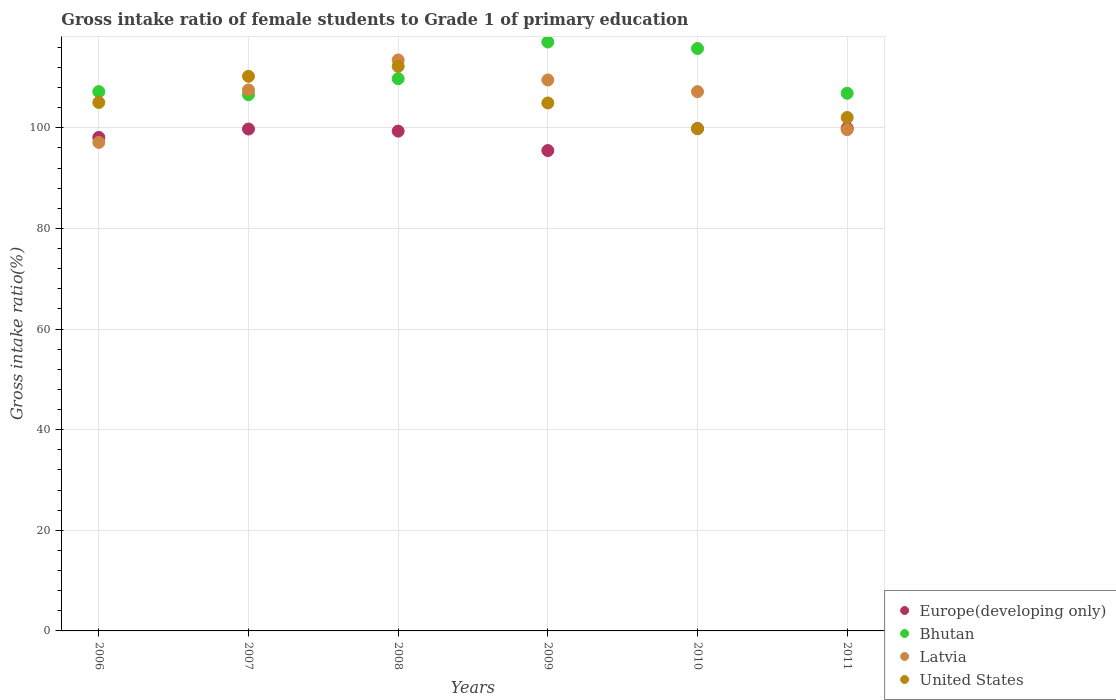How many different coloured dotlines are there?
Make the answer very short. 4. What is the gross intake ratio in Europe(developing only) in 2008?
Keep it short and to the point. 99.34. Across all years, what is the maximum gross intake ratio in Latvia?
Offer a terse response. 113.48. Across all years, what is the minimum gross intake ratio in Bhutan?
Your answer should be very brief. 106.58. In which year was the gross intake ratio in United States minimum?
Provide a short and direct response. 2010. What is the total gross intake ratio in Latvia in the graph?
Your answer should be compact. 634.45. What is the difference between the gross intake ratio in Bhutan in 2007 and that in 2011?
Offer a very short reply. -0.28. What is the difference between the gross intake ratio in Bhutan in 2006 and the gross intake ratio in Europe(developing only) in 2008?
Your answer should be very brief. 7.85. What is the average gross intake ratio in Bhutan per year?
Your answer should be compact. 110.54. In the year 2007, what is the difference between the gross intake ratio in Europe(developing only) and gross intake ratio in Bhutan?
Offer a very short reply. -6.82. In how many years, is the gross intake ratio in Europe(developing only) greater than 76 %?
Offer a terse response. 6. What is the ratio of the gross intake ratio in Latvia in 2006 to that in 2008?
Keep it short and to the point. 0.86. What is the difference between the highest and the second highest gross intake ratio in Bhutan?
Provide a short and direct response. 1.3. What is the difference between the highest and the lowest gross intake ratio in Europe(developing only)?
Provide a succinct answer. 4.46. In how many years, is the gross intake ratio in United States greater than the average gross intake ratio in United States taken over all years?
Your answer should be compact. 2. Is the gross intake ratio in Bhutan strictly greater than the gross intake ratio in Europe(developing only) over the years?
Provide a short and direct response. Yes. What is the difference between two consecutive major ticks on the Y-axis?
Ensure brevity in your answer.  20. How many legend labels are there?
Offer a terse response. 4. What is the title of the graph?
Give a very brief answer. Gross intake ratio of female students to Grade 1 of primary education. What is the label or title of the Y-axis?
Make the answer very short. Gross intake ratio(%). What is the Gross intake ratio(%) in Europe(developing only) in 2006?
Offer a terse response. 98.09. What is the Gross intake ratio(%) in Bhutan in 2006?
Give a very brief answer. 107.19. What is the Gross intake ratio(%) in Latvia in 2006?
Your response must be concise. 97.1. What is the Gross intake ratio(%) in United States in 2006?
Your answer should be very brief. 105.04. What is the Gross intake ratio(%) in Europe(developing only) in 2007?
Your answer should be very brief. 99.76. What is the Gross intake ratio(%) in Bhutan in 2007?
Your answer should be very brief. 106.58. What is the Gross intake ratio(%) of Latvia in 2007?
Provide a succinct answer. 107.53. What is the Gross intake ratio(%) of United States in 2007?
Your answer should be very brief. 110.24. What is the Gross intake ratio(%) in Europe(developing only) in 2008?
Your answer should be compact. 99.34. What is the Gross intake ratio(%) of Bhutan in 2008?
Provide a short and direct response. 109.76. What is the Gross intake ratio(%) in Latvia in 2008?
Your answer should be compact. 113.48. What is the Gross intake ratio(%) in United States in 2008?
Keep it short and to the point. 112.22. What is the Gross intake ratio(%) in Europe(developing only) in 2009?
Ensure brevity in your answer.  95.48. What is the Gross intake ratio(%) in Bhutan in 2009?
Provide a short and direct response. 117.06. What is the Gross intake ratio(%) in Latvia in 2009?
Ensure brevity in your answer.  109.51. What is the Gross intake ratio(%) in United States in 2009?
Provide a short and direct response. 104.94. What is the Gross intake ratio(%) of Europe(developing only) in 2010?
Keep it short and to the point. 99.87. What is the Gross intake ratio(%) in Bhutan in 2010?
Your answer should be compact. 115.76. What is the Gross intake ratio(%) of Latvia in 2010?
Your response must be concise. 107.19. What is the Gross intake ratio(%) in United States in 2010?
Your answer should be compact. 99.82. What is the Gross intake ratio(%) in Europe(developing only) in 2011?
Offer a very short reply. 99.94. What is the Gross intake ratio(%) in Bhutan in 2011?
Ensure brevity in your answer.  106.86. What is the Gross intake ratio(%) of Latvia in 2011?
Your response must be concise. 99.64. What is the Gross intake ratio(%) in United States in 2011?
Your response must be concise. 102.05. Across all years, what is the maximum Gross intake ratio(%) in Europe(developing only)?
Your answer should be very brief. 99.94. Across all years, what is the maximum Gross intake ratio(%) in Bhutan?
Your response must be concise. 117.06. Across all years, what is the maximum Gross intake ratio(%) of Latvia?
Make the answer very short. 113.48. Across all years, what is the maximum Gross intake ratio(%) of United States?
Your answer should be very brief. 112.22. Across all years, what is the minimum Gross intake ratio(%) in Europe(developing only)?
Your answer should be very brief. 95.48. Across all years, what is the minimum Gross intake ratio(%) of Bhutan?
Ensure brevity in your answer.  106.58. Across all years, what is the minimum Gross intake ratio(%) of Latvia?
Your answer should be very brief. 97.1. Across all years, what is the minimum Gross intake ratio(%) of United States?
Give a very brief answer. 99.82. What is the total Gross intake ratio(%) of Europe(developing only) in the graph?
Your answer should be very brief. 592.47. What is the total Gross intake ratio(%) in Bhutan in the graph?
Provide a short and direct response. 663.22. What is the total Gross intake ratio(%) in Latvia in the graph?
Give a very brief answer. 634.45. What is the total Gross intake ratio(%) in United States in the graph?
Offer a very short reply. 634.31. What is the difference between the Gross intake ratio(%) of Europe(developing only) in 2006 and that in 2007?
Make the answer very short. -1.67. What is the difference between the Gross intake ratio(%) in Bhutan in 2006 and that in 2007?
Keep it short and to the point. 0.61. What is the difference between the Gross intake ratio(%) in Latvia in 2006 and that in 2007?
Provide a succinct answer. -10.42. What is the difference between the Gross intake ratio(%) in United States in 2006 and that in 2007?
Make the answer very short. -5.2. What is the difference between the Gross intake ratio(%) of Europe(developing only) in 2006 and that in 2008?
Provide a succinct answer. -1.25. What is the difference between the Gross intake ratio(%) in Bhutan in 2006 and that in 2008?
Provide a short and direct response. -2.57. What is the difference between the Gross intake ratio(%) in Latvia in 2006 and that in 2008?
Give a very brief answer. -16.38. What is the difference between the Gross intake ratio(%) of United States in 2006 and that in 2008?
Your response must be concise. -7.18. What is the difference between the Gross intake ratio(%) of Europe(developing only) in 2006 and that in 2009?
Your answer should be very brief. 2.61. What is the difference between the Gross intake ratio(%) of Bhutan in 2006 and that in 2009?
Give a very brief answer. -9.86. What is the difference between the Gross intake ratio(%) of Latvia in 2006 and that in 2009?
Offer a terse response. -12.41. What is the difference between the Gross intake ratio(%) of United States in 2006 and that in 2009?
Keep it short and to the point. 0.1. What is the difference between the Gross intake ratio(%) in Europe(developing only) in 2006 and that in 2010?
Offer a very short reply. -1.77. What is the difference between the Gross intake ratio(%) of Bhutan in 2006 and that in 2010?
Keep it short and to the point. -8.57. What is the difference between the Gross intake ratio(%) in Latvia in 2006 and that in 2010?
Make the answer very short. -10.09. What is the difference between the Gross intake ratio(%) of United States in 2006 and that in 2010?
Make the answer very short. 5.21. What is the difference between the Gross intake ratio(%) in Europe(developing only) in 2006 and that in 2011?
Provide a succinct answer. -1.85. What is the difference between the Gross intake ratio(%) in Bhutan in 2006 and that in 2011?
Keep it short and to the point. 0.33. What is the difference between the Gross intake ratio(%) in Latvia in 2006 and that in 2011?
Keep it short and to the point. -2.54. What is the difference between the Gross intake ratio(%) of United States in 2006 and that in 2011?
Ensure brevity in your answer.  2.98. What is the difference between the Gross intake ratio(%) in Europe(developing only) in 2007 and that in 2008?
Provide a succinct answer. 0.42. What is the difference between the Gross intake ratio(%) in Bhutan in 2007 and that in 2008?
Keep it short and to the point. -3.18. What is the difference between the Gross intake ratio(%) in Latvia in 2007 and that in 2008?
Keep it short and to the point. -5.96. What is the difference between the Gross intake ratio(%) of United States in 2007 and that in 2008?
Offer a terse response. -1.98. What is the difference between the Gross intake ratio(%) of Europe(developing only) in 2007 and that in 2009?
Offer a very short reply. 4.28. What is the difference between the Gross intake ratio(%) of Bhutan in 2007 and that in 2009?
Provide a short and direct response. -10.48. What is the difference between the Gross intake ratio(%) in Latvia in 2007 and that in 2009?
Ensure brevity in your answer.  -1.98. What is the difference between the Gross intake ratio(%) in United States in 2007 and that in 2009?
Provide a succinct answer. 5.3. What is the difference between the Gross intake ratio(%) of Europe(developing only) in 2007 and that in 2010?
Your answer should be compact. -0.1. What is the difference between the Gross intake ratio(%) of Bhutan in 2007 and that in 2010?
Offer a terse response. -9.18. What is the difference between the Gross intake ratio(%) in Latvia in 2007 and that in 2010?
Offer a terse response. 0.34. What is the difference between the Gross intake ratio(%) in United States in 2007 and that in 2010?
Provide a succinct answer. 10.41. What is the difference between the Gross intake ratio(%) of Europe(developing only) in 2007 and that in 2011?
Ensure brevity in your answer.  -0.17. What is the difference between the Gross intake ratio(%) of Bhutan in 2007 and that in 2011?
Keep it short and to the point. -0.28. What is the difference between the Gross intake ratio(%) of Latvia in 2007 and that in 2011?
Ensure brevity in your answer.  7.89. What is the difference between the Gross intake ratio(%) in United States in 2007 and that in 2011?
Your response must be concise. 8.19. What is the difference between the Gross intake ratio(%) in Europe(developing only) in 2008 and that in 2009?
Keep it short and to the point. 3.86. What is the difference between the Gross intake ratio(%) in Bhutan in 2008 and that in 2009?
Offer a terse response. -7.29. What is the difference between the Gross intake ratio(%) in Latvia in 2008 and that in 2009?
Your response must be concise. 3.97. What is the difference between the Gross intake ratio(%) in United States in 2008 and that in 2009?
Offer a very short reply. 7.29. What is the difference between the Gross intake ratio(%) in Europe(developing only) in 2008 and that in 2010?
Provide a succinct answer. -0.53. What is the difference between the Gross intake ratio(%) of Bhutan in 2008 and that in 2010?
Your answer should be very brief. -6. What is the difference between the Gross intake ratio(%) of Latvia in 2008 and that in 2010?
Your response must be concise. 6.3. What is the difference between the Gross intake ratio(%) of United States in 2008 and that in 2010?
Provide a succinct answer. 12.4. What is the difference between the Gross intake ratio(%) of Europe(developing only) in 2008 and that in 2011?
Your answer should be compact. -0.6. What is the difference between the Gross intake ratio(%) of Bhutan in 2008 and that in 2011?
Give a very brief answer. 2.9. What is the difference between the Gross intake ratio(%) in Latvia in 2008 and that in 2011?
Make the answer very short. 13.85. What is the difference between the Gross intake ratio(%) in United States in 2008 and that in 2011?
Your answer should be compact. 10.17. What is the difference between the Gross intake ratio(%) in Europe(developing only) in 2009 and that in 2010?
Offer a very short reply. -4.39. What is the difference between the Gross intake ratio(%) of Bhutan in 2009 and that in 2010?
Provide a succinct answer. 1.3. What is the difference between the Gross intake ratio(%) of Latvia in 2009 and that in 2010?
Provide a succinct answer. 2.32. What is the difference between the Gross intake ratio(%) in United States in 2009 and that in 2010?
Give a very brief answer. 5.11. What is the difference between the Gross intake ratio(%) of Europe(developing only) in 2009 and that in 2011?
Your answer should be very brief. -4.46. What is the difference between the Gross intake ratio(%) of Bhutan in 2009 and that in 2011?
Provide a succinct answer. 10.19. What is the difference between the Gross intake ratio(%) in Latvia in 2009 and that in 2011?
Offer a very short reply. 9.87. What is the difference between the Gross intake ratio(%) in United States in 2009 and that in 2011?
Provide a short and direct response. 2.88. What is the difference between the Gross intake ratio(%) in Europe(developing only) in 2010 and that in 2011?
Your answer should be compact. -0.07. What is the difference between the Gross intake ratio(%) in Bhutan in 2010 and that in 2011?
Your answer should be compact. 8.9. What is the difference between the Gross intake ratio(%) of Latvia in 2010 and that in 2011?
Offer a terse response. 7.55. What is the difference between the Gross intake ratio(%) in United States in 2010 and that in 2011?
Ensure brevity in your answer.  -2.23. What is the difference between the Gross intake ratio(%) of Europe(developing only) in 2006 and the Gross intake ratio(%) of Bhutan in 2007?
Your answer should be very brief. -8.49. What is the difference between the Gross intake ratio(%) in Europe(developing only) in 2006 and the Gross intake ratio(%) in Latvia in 2007?
Provide a short and direct response. -9.44. What is the difference between the Gross intake ratio(%) of Europe(developing only) in 2006 and the Gross intake ratio(%) of United States in 2007?
Offer a very short reply. -12.15. What is the difference between the Gross intake ratio(%) in Bhutan in 2006 and the Gross intake ratio(%) in Latvia in 2007?
Your answer should be very brief. -0.33. What is the difference between the Gross intake ratio(%) in Bhutan in 2006 and the Gross intake ratio(%) in United States in 2007?
Your answer should be compact. -3.04. What is the difference between the Gross intake ratio(%) in Latvia in 2006 and the Gross intake ratio(%) in United States in 2007?
Keep it short and to the point. -13.14. What is the difference between the Gross intake ratio(%) of Europe(developing only) in 2006 and the Gross intake ratio(%) of Bhutan in 2008?
Keep it short and to the point. -11.67. What is the difference between the Gross intake ratio(%) in Europe(developing only) in 2006 and the Gross intake ratio(%) in Latvia in 2008?
Keep it short and to the point. -15.39. What is the difference between the Gross intake ratio(%) in Europe(developing only) in 2006 and the Gross intake ratio(%) in United States in 2008?
Offer a terse response. -14.13. What is the difference between the Gross intake ratio(%) of Bhutan in 2006 and the Gross intake ratio(%) of Latvia in 2008?
Your answer should be compact. -6.29. What is the difference between the Gross intake ratio(%) in Bhutan in 2006 and the Gross intake ratio(%) in United States in 2008?
Give a very brief answer. -5.03. What is the difference between the Gross intake ratio(%) in Latvia in 2006 and the Gross intake ratio(%) in United States in 2008?
Offer a very short reply. -15.12. What is the difference between the Gross intake ratio(%) of Europe(developing only) in 2006 and the Gross intake ratio(%) of Bhutan in 2009?
Provide a short and direct response. -18.97. What is the difference between the Gross intake ratio(%) of Europe(developing only) in 2006 and the Gross intake ratio(%) of Latvia in 2009?
Provide a short and direct response. -11.42. What is the difference between the Gross intake ratio(%) in Europe(developing only) in 2006 and the Gross intake ratio(%) in United States in 2009?
Make the answer very short. -6.84. What is the difference between the Gross intake ratio(%) of Bhutan in 2006 and the Gross intake ratio(%) of Latvia in 2009?
Keep it short and to the point. -2.32. What is the difference between the Gross intake ratio(%) in Bhutan in 2006 and the Gross intake ratio(%) in United States in 2009?
Offer a very short reply. 2.26. What is the difference between the Gross intake ratio(%) of Latvia in 2006 and the Gross intake ratio(%) of United States in 2009?
Your response must be concise. -7.83. What is the difference between the Gross intake ratio(%) of Europe(developing only) in 2006 and the Gross intake ratio(%) of Bhutan in 2010?
Offer a very short reply. -17.67. What is the difference between the Gross intake ratio(%) of Europe(developing only) in 2006 and the Gross intake ratio(%) of Latvia in 2010?
Ensure brevity in your answer.  -9.1. What is the difference between the Gross intake ratio(%) of Europe(developing only) in 2006 and the Gross intake ratio(%) of United States in 2010?
Offer a very short reply. -1.73. What is the difference between the Gross intake ratio(%) of Bhutan in 2006 and the Gross intake ratio(%) of Latvia in 2010?
Your answer should be very brief. 0.01. What is the difference between the Gross intake ratio(%) of Bhutan in 2006 and the Gross intake ratio(%) of United States in 2010?
Offer a very short reply. 7.37. What is the difference between the Gross intake ratio(%) of Latvia in 2006 and the Gross intake ratio(%) of United States in 2010?
Offer a terse response. -2.72. What is the difference between the Gross intake ratio(%) of Europe(developing only) in 2006 and the Gross intake ratio(%) of Bhutan in 2011?
Provide a short and direct response. -8.77. What is the difference between the Gross intake ratio(%) in Europe(developing only) in 2006 and the Gross intake ratio(%) in Latvia in 2011?
Ensure brevity in your answer.  -1.55. What is the difference between the Gross intake ratio(%) of Europe(developing only) in 2006 and the Gross intake ratio(%) of United States in 2011?
Your response must be concise. -3.96. What is the difference between the Gross intake ratio(%) of Bhutan in 2006 and the Gross intake ratio(%) of Latvia in 2011?
Provide a short and direct response. 7.56. What is the difference between the Gross intake ratio(%) in Bhutan in 2006 and the Gross intake ratio(%) in United States in 2011?
Offer a very short reply. 5.14. What is the difference between the Gross intake ratio(%) of Latvia in 2006 and the Gross intake ratio(%) of United States in 2011?
Make the answer very short. -4.95. What is the difference between the Gross intake ratio(%) in Europe(developing only) in 2007 and the Gross intake ratio(%) in Bhutan in 2008?
Ensure brevity in your answer.  -10. What is the difference between the Gross intake ratio(%) in Europe(developing only) in 2007 and the Gross intake ratio(%) in Latvia in 2008?
Give a very brief answer. -13.72. What is the difference between the Gross intake ratio(%) of Europe(developing only) in 2007 and the Gross intake ratio(%) of United States in 2008?
Give a very brief answer. -12.46. What is the difference between the Gross intake ratio(%) of Bhutan in 2007 and the Gross intake ratio(%) of Latvia in 2008?
Provide a short and direct response. -6.9. What is the difference between the Gross intake ratio(%) of Bhutan in 2007 and the Gross intake ratio(%) of United States in 2008?
Your response must be concise. -5.64. What is the difference between the Gross intake ratio(%) of Latvia in 2007 and the Gross intake ratio(%) of United States in 2008?
Make the answer very short. -4.69. What is the difference between the Gross intake ratio(%) of Europe(developing only) in 2007 and the Gross intake ratio(%) of Bhutan in 2009?
Give a very brief answer. -17.29. What is the difference between the Gross intake ratio(%) in Europe(developing only) in 2007 and the Gross intake ratio(%) in Latvia in 2009?
Provide a short and direct response. -9.75. What is the difference between the Gross intake ratio(%) of Europe(developing only) in 2007 and the Gross intake ratio(%) of United States in 2009?
Your answer should be compact. -5.17. What is the difference between the Gross intake ratio(%) of Bhutan in 2007 and the Gross intake ratio(%) of Latvia in 2009?
Make the answer very short. -2.93. What is the difference between the Gross intake ratio(%) of Bhutan in 2007 and the Gross intake ratio(%) of United States in 2009?
Ensure brevity in your answer.  1.65. What is the difference between the Gross intake ratio(%) of Latvia in 2007 and the Gross intake ratio(%) of United States in 2009?
Provide a succinct answer. 2.59. What is the difference between the Gross intake ratio(%) in Europe(developing only) in 2007 and the Gross intake ratio(%) in Bhutan in 2010?
Keep it short and to the point. -16. What is the difference between the Gross intake ratio(%) of Europe(developing only) in 2007 and the Gross intake ratio(%) of Latvia in 2010?
Keep it short and to the point. -7.43. What is the difference between the Gross intake ratio(%) of Europe(developing only) in 2007 and the Gross intake ratio(%) of United States in 2010?
Ensure brevity in your answer.  -0.06. What is the difference between the Gross intake ratio(%) in Bhutan in 2007 and the Gross intake ratio(%) in Latvia in 2010?
Your answer should be compact. -0.61. What is the difference between the Gross intake ratio(%) of Bhutan in 2007 and the Gross intake ratio(%) of United States in 2010?
Ensure brevity in your answer.  6.76. What is the difference between the Gross intake ratio(%) of Latvia in 2007 and the Gross intake ratio(%) of United States in 2010?
Offer a terse response. 7.7. What is the difference between the Gross intake ratio(%) of Europe(developing only) in 2007 and the Gross intake ratio(%) of Bhutan in 2011?
Provide a short and direct response. -7.1. What is the difference between the Gross intake ratio(%) in Europe(developing only) in 2007 and the Gross intake ratio(%) in Latvia in 2011?
Make the answer very short. 0.12. What is the difference between the Gross intake ratio(%) of Europe(developing only) in 2007 and the Gross intake ratio(%) of United States in 2011?
Your answer should be very brief. -2.29. What is the difference between the Gross intake ratio(%) of Bhutan in 2007 and the Gross intake ratio(%) of Latvia in 2011?
Give a very brief answer. 6.94. What is the difference between the Gross intake ratio(%) in Bhutan in 2007 and the Gross intake ratio(%) in United States in 2011?
Your answer should be compact. 4.53. What is the difference between the Gross intake ratio(%) of Latvia in 2007 and the Gross intake ratio(%) of United States in 2011?
Your response must be concise. 5.47. What is the difference between the Gross intake ratio(%) of Europe(developing only) in 2008 and the Gross intake ratio(%) of Bhutan in 2009?
Ensure brevity in your answer.  -17.72. What is the difference between the Gross intake ratio(%) of Europe(developing only) in 2008 and the Gross intake ratio(%) of Latvia in 2009?
Your response must be concise. -10.17. What is the difference between the Gross intake ratio(%) of Europe(developing only) in 2008 and the Gross intake ratio(%) of United States in 2009?
Ensure brevity in your answer.  -5.59. What is the difference between the Gross intake ratio(%) of Bhutan in 2008 and the Gross intake ratio(%) of Latvia in 2009?
Your answer should be compact. 0.25. What is the difference between the Gross intake ratio(%) of Bhutan in 2008 and the Gross intake ratio(%) of United States in 2009?
Your answer should be compact. 4.83. What is the difference between the Gross intake ratio(%) of Latvia in 2008 and the Gross intake ratio(%) of United States in 2009?
Make the answer very short. 8.55. What is the difference between the Gross intake ratio(%) of Europe(developing only) in 2008 and the Gross intake ratio(%) of Bhutan in 2010?
Give a very brief answer. -16.42. What is the difference between the Gross intake ratio(%) of Europe(developing only) in 2008 and the Gross intake ratio(%) of Latvia in 2010?
Keep it short and to the point. -7.85. What is the difference between the Gross intake ratio(%) of Europe(developing only) in 2008 and the Gross intake ratio(%) of United States in 2010?
Provide a succinct answer. -0.48. What is the difference between the Gross intake ratio(%) in Bhutan in 2008 and the Gross intake ratio(%) in Latvia in 2010?
Provide a succinct answer. 2.57. What is the difference between the Gross intake ratio(%) of Bhutan in 2008 and the Gross intake ratio(%) of United States in 2010?
Offer a terse response. 9.94. What is the difference between the Gross intake ratio(%) in Latvia in 2008 and the Gross intake ratio(%) in United States in 2010?
Provide a succinct answer. 13.66. What is the difference between the Gross intake ratio(%) in Europe(developing only) in 2008 and the Gross intake ratio(%) in Bhutan in 2011?
Your answer should be very brief. -7.52. What is the difference between the Gross intake ratio(%) in Europe(developing only) in 2008 and the Gross intake ratio(%) in Latvia in 2011?
Your answer should be very brief. -0.3. What is the difference between the Gross intake ratio(%) of Europe(developing only) in 2008 and the Gross intake ratio(%) of United States in 2011?
Offer a terse response. -2.71. What is the difference between the Gross intake ratio(%) of Bhutan in 2008 and the Gross intake ratio(%) of Latvia in 2011?
Provide a short and direct response. 10.12. What is the difference between the Gross intake ratio(%) in Bhutan in 2008 and the Gross intake ratio(%) in United States in 2011?
Ensure brevity in your answer.  7.71. What is the difference between the Gross intake ratio(%) in Latvia in 2008 and the Gross intake ratio(%) in United States in 2011?
Your response must be concise. 11.43. What is the difference between the Gross intake ratio(%) in Europe(developing only) in 2009 and the Gross intake ratio(%) in Bhutan in 2010?
Ensure brevity in your answer.  -20.28. What is the difference between the Gross intake ratio(%) in Europe(developing only) in 2009 and the Gross intake ratio(%) in Latvia in 2010?
Provide a short and direct response. -11.71. What is the difference between the Gross intake ratio(%) in Europe(developing only) in 2009 and the Gross intake ratio(%) in United States in 2010?
Provide a succinct answer. -4.35. What is the difference between the Gross intake ratio(%) in Bhutan in 2009 and the Gross intake ratio(%) in Latvia in 2010?
Keep it short and to the point. 9.87. What is the difference between the Gross intake ratio(%) in Bhutan in 2009 and the Gross intake ratio(%) in United States in 2010?
Your answer should be very brief. 17.23. What is the difference between the Gross intake ratio(%) in Latvia in 2009 and the Gross intake ratio(%) in United States in 2010?
Your answer should be compact. 9.69. What is the difference between the Gross intake ratio(%) of Europe(developing only) in 2009 and the Gross intake ratio(%) of Bhutan in 2011?
Give a very brief answer. -11.38. What is the difference between the Gross intake ratio(%) in Europe(developing only) in 2009 and the Gross intake ratio(%) in Latvia in 2011?
Your response must be concise. -4.16. What is the difference between the Gross intake ratio(%) in Europe(developing only) in 2009 and the Gross intake ratio(%) in United States in 2011?
Provide a short and direct response. -6.57. What is the difference between the Gross intake ratio(%) of Bhutan in 2009 and the Gross intake ratio(%) of Latvia in 2011?
Your response must be concise. 17.42. What is the difference between the Gross intake ratio(%) in Bhutan in 2009 and the Gross intake ratio(%) in United States in 2011?
Your answer should be compact. 15. What is the difference between the Gross intake ratio(%) of Latvia in 2009 and the Gross intake ratio(%) of United States in 2011?
Offer a very short reply. 7.46. What is the difference between the Gross intake ratio(%) of Europe(developing only) in 2010 and the Gross intake ratio(%) of Bhutan in 2011?
Keep it short and to the point. -7. What is the difference between the Gross intake ratio(%) of Europe(developing only) in 2010 and the Gross intake ratio(%) of Latvia in 2011?
Make the answer very short. 0.23. What is the difference between the Gross intake ratio(%) of Europe(developing only) in 2010 and the Gross intake ratio(%) of United States in 2011?
Keep it short and to the point. -2.19. What is the difference between the Gross intake ratio(%) of Bhutan in 2010 and the Gross intake ratio(%) of Latvia in 2011?
Give a very brief answer. 16.12. What is the difference between the Gross intake ratio(%) of Bhutan in 2010 and the Gross intake ratio(%) of United States in 2011?
Give a very brief answer. 13.71. What is the difference between the Gross intake ratio(%) in Latvia in 2010 and the Gross intake ratio(%) in United States in 2011?
Offer a terse response. 5.14. What is the average Gross intake ratio(%) of Europe(developing only) per year?
Keep it short and to the point. 98.75. What is the average Gross intake ratio(%) of Bhutan per year?
Give a very brief answer. 110.54. What is the average Gross intake ratio(%) in Latvia per year?
Give a very brief answer. 105.74. What is the average Gross intake ratio(%) of United States per year?
Your answer should be compact. 105.72. In the year 2006, what is the difference between the Gross intake ratio(%) in Europe(developing only) and Gross intake ratio(%) in Bhutan?
Offer a terse response. -9.1. In the year 2006, what is the difference between the Gross intake ratio(%) in Europe(developing only) and Gross intake ratio(%) in Latvia?
Provide a short and direct response. 0.99. In the year 2006, what is the difference between the Gross intake ratio(%) of Europe(developing only) and Gross intake ratio(%) of United States?
Provide a short and direct response. -6.95. In the year 2006, what is the difference between the Gross intake ratio(%) in Bhutan and Gross intake ratio(%) in Latvia?
Offer a very short reply. 10.09. In the year 2006, what is the difference between the Gross intake ratio(%) in Bhutan and Gross intake ratio(%) in United States?
Provide a short and direct response. 2.16. In the year 2006, what is the difference between the Gross intake ratio(%) in Latvia and Gross intake ratio(%) in United States?
Your answer should be compact. -7.93. In the year 2007, what is the difference between the Gross intake ratio(%) of Europe(developing only) and Gross intake ratio(%) of Bhutan?
Your answer should be compact. -6.82. In the year 2007, what is the difference between the Gross intake ratio(%) in Europe(developing only) and Gross intake ratio(%) in Latvia?
Provide a succinct answer. -7.76. In the year 2007, what is the difference between the Gross intake ratio(%) of Europe(developing only) and Gross intake ratio(%) of United States?
Ensure brevity in your answer.  -10.48. In the year 2007, what is the difference between the Gross intake ratio(%) of Bhutan and Gross intake ratio(%) of Latvia?
Offer a terse response. -0.95. In the year 2007, what is the difference between the Gross intake ratio(%) in Bhutan and Gross intake ratio(%) in United States?
Make the answer very short. -3.66. In the year 2007, what is the difference between the Gross intake ratio(%) of Latvia and Gross intake ratio(%) of United States?
Ensure brevity in your answer.  -2.71. In the year 2008, what is the difference between the Gross intake ratio(%) of Europe(developing only) and Gross intake ratio(%) of Bhutan?
Your answer should be very brief. -10.42. In the year 2008, what is the difference between the Gross intake ratio(%) in Europe(developing only) and Gross intake ratio(%) in Latvia?
Your answer should be very brief. -14.14. In the year 2008, what is the difference between the Gross intake ratio(%) in Europe(developing only) and Gross intake ratio(%) in United States?
Provide a short and direct response. -12.88. In the year 2008, what is the difference between the Gross intake ratio(%) of Bhutan and Gross intake ratio(%) of Latvia?
Make the answer very short. -3.72. In the year 2008, what is the difference between the Gross intake ratio(%) of Bhutan and Gross intake ratio(%) of United States?
Make the answer very short. -2.46. In the year 2008, what is the difference between the Gross intake ratio(%) of Latvia and Gross intake ratio(%) of United States?
Keep it short and to the point. 1.26. In the year 2009, what is the difference between the Gross intake ratio(%) in Europe(developing only) and Gross intake ratio(%) in Bhutan?
Provide a succinct answer. -21.58. In the year 2009, what is the difference between the Gross intake ratio(%) in Europe(developing only) and Gross intake ratio(%) in Latvia?
Give a very brief answer. -14.03. In the year 2009, what is the difference between the Gross intake ratio(%) in Europe(developing only) and Gross intake ratio(%) in United States?
Provide a succinct answer. -9.46. In the year 2009, what is the difference between the Gross intake ratio(%) in Bhutan and Gross intake ratio(%) in Latvia?
Your answer should be compact. 7.55. In the year 2009, what is the difference between the Gross intake ratio(%) in Bhutan and Gross intake ratio(%) in United States?
Provide a short and direct response. 12.12. In the year 2009, what is the difference between the Gross intake ratio(%) in Latvia and Gross intake ratio(%) in United States?
Your answer should be very brief. 4.58. In the year 2010, what is the difference between the Gross intake ratio(%) in Europe(developing only) and Gross intake ratio(%) in Bhutan?
Provide a succinct answer. -15.9. In the year 2010, what is the difference between the Gross intake ratio(%) of Europe(developing only) and Gross intake ratio(%) of Latvia?
Offer a terse response. -7.32. In the year 2010, what is the difference between the Gross intake ratio(%) in Europe(developing only) and Gross intake ratio(%) in United States?
Offer a terse response. 0.04. In the year 2010, what is the difference between the Gross intake ratio(%) of Bhutan and Gross intake ratio(%) of Latvia?
Provide a succinct answer. 8.57. In the year 2010, what is the difference between the Gross intake ratio(%) of Bhutan and Gross intake ratio(%) of United States?
Your answer should be compact. 15.94. In the year 2010, what is the difference between the Gross intake ratio(%) in Latvia and Gross intake ratio(%) in United States?
Your answer should be compact. 7.36. In the year 2011, what is the difference between the Gross intake ratio(%) of Europe(developing only) and Gross intake ratio(%) of Bhutan?
Provide a short and direct response. -6.93. In the year 2011, what is the difference between the Gross intake ratio(%) of Europe(developing only) and Gross intake ratio(%) of Latvia?
Provide a short and direct response. 0.3. In the year 2011, what is the difference between the Gross intake ratio(%) in Europe(developing only) and Gross intake ratio(%) in United States?
Offer a very short reply. -2.12. In the year 2011, what is the difference between the Gross intake ratio(%) of Bhutan and Gross intake ratio(%) of Latvia?
Your answer should be very brief. 7.22. In the year 2011, what is the difference between the Gross intake ratio(%) in Bhutan and Gross intake ratio(%) in United States?
Give a very brief answer. 4.81. In the year 2011, what is the difference between the Gross intake ratio(%) in Latvia and Gross intake ratio(%) in United States?
Offer a terse response. -2.42. What is the ratio of the Gross intake ratio(%) of Europe(developing only) in 2006 to that in 2007?
Offer a terse response. 0.98. What is the ratio of the Gross intake ratio(%) of Bhutan in 2006 to that in 2007?
Offer a very short reply. 1.01. What is the ratio of the Gross intake ratio(%) of Latvia in 2006 to that in 2007?
Provide a short and direct response. 0.9. What is the ratio of the Gross intake ratio(%) in United States in 2006 to that in 2007?
Keep it short and to the point. 0.95. What is the ratio of the Gross intake ratio(%) of Europe(developing only) in 2006 to that in 2008?
Offer a terse response. 0.99. What is the ratio of the Gross intake ratio(%) in Bhutan in 2006 to that in 2008?
Provide a succinct answer. 0.98. What is the ratio of the Gross intake ratio(%) of Latvia in 2006 to that in 2008?
Your response must be concise. 0.86. What is the ratio of the Gross intake ratio(%) of United States in 2006 to that in 2008?
Your answer should be very brief. 0.94. What is the ratio of the Gross intake ratio(%) of Europe(developing only) in 2006 to that in 2009?
Provide a short and direct response. 1.03. What is the ratio of the Gross intake ratio(%) in Bhutan in 2006 to that in 2009?
Ensure brevity in your answer.  0.92. What is the ratio of the Gross intake ratio(%) in Latvia in 2006 to that in 2009?
Offer a very short reply. 0.89. What is the ratio of the Gross intake ratio(%) of Europe(developing only) in 2006 to that in 2010?
Give a very brief answer. 0.98. What is the ratio of the Gross intake ratio(%) in Bhutan in 2006 to that in 2010?
Your response must be concise. 0.93. What is the ratio of the Gross intake ratio(%) in Latvia in 2006 to that in 2010?
Provide a succinct answer. 0.91. What is the ratio of the Gross intake ratio(%) of United States in 2006 to that in 2010?
Your answer should be very brief. 1.05. What is the ratio of the Gross intake ratio(%) of Europe(developing only) in 2006 to that in 2011?
Ensure brevity in your answer.  0.98. What is the ratio of the Gross intake ratio(%) of Latvia in 2006 to that in 2011?
Your answer should be compact. 0.97. What is the ratio of the Gross intake ratio(%) in United States in 2006 to that in 2011?
Ensure brevity in your answer.  1.03. What is the ratio of the Gross intake ratio(%) of Europe(developing only) in 2007 to that in 2008?
Give a very brief answer. 1. What is the ratio of the Gross intake ratio(%) of Bhutan in 2007 to that in 2008?
Offer a terse response. 0.97. What is the ratio of the Gross intake ratio(%) in Latvia in 2007 to that in 2008?
Your answer should be very brief. 0.95. What is the ratio of the Gross intake ratio(%) of United States in 2007 to that in 2008?
Provide a succinct answer. 0.98. What is the ratio of the Gross intake ratio(%) of Europe(developing only) in 2007 to that in 2009?
Your answer should be very brief. 1.04. What is the ratio of the Gross intake ratio(%) in Bhutan in 2007 to that in 2009?
Your response must be concise. 0.91. What is the ratio of the Gross intake ratio(%) of Latvia in 2007 to that in 2009?
Make the answer very short. 0.98. What is the ratio of the Gross intake ratio(%) in United States in 2007 to that in 2009?
Keep it short and to the point. 1.05. What is the ratio of the Gross intake ratio(%) of Bhutan in 2007 to that in 2010?
Provide a succinct answer. 0.92. What is the ratio of the Gross intake ratio(%) of United States in 2007 to that in 2010?
Provide a succinct answer. 1.1. What is the ratio of the Gross intake ratio(%) in Latvia in 2007 to that in 2011?
Your answer should be compact. 1.08. What is the ratio of the Gross intake ratio(%) in United States in 2007 to that in 2011?
Make the answer very short. 1.08. What is the ratio of the Gross intake ratio(%) in Europe(developing only) in 2008 to that in 2009?
Your response must be concise. 1.04. What is the ratio of the Gross intake ratio(%) of Bhutan in 2008 to that in 2009?
Ensure brevity in your answer.  0.94. What is the ratio of the Gross intake ratio(%) of Latvia in 2008 to that in 2009?
Your response must be concise. 1.04. What is the ratio of the Gross intake ratio(%) in United States in 2008 to that in 2009?
Offer a very short reply. 1.07. What is the ratio of the Gross intake ratio(%) of Europe(developing only) in 2008 to that in 2010?
Make the answer very short. 0.99. What is the ratio of the Gross intake ratio(%) in Bhutan in 2008 to that in 2010?
Provide a succinct answer. 0.95. What is the ratio of the Gross intake ratio(%) of Latvia in 2008 to that in 2010?
Ensure brevity in your answer.  1.06. What is the ratio of the Gross intake ratio(%) of United States in 2008 to that in 2010?
Keep it short and to the point. 1.12. What is the ratio of the Gross intake ratio(%) of Bhutan in 2008 to that in 2011?
Make the answer very short. 1.03. What is the ratio of the Gross intake ratio(%) of Latvia in 2008 to that in 2011?
Your answer should be very brief. 1.14. What is the ratio of the Gross intake ratio(%) in United States in 2008 to that in 2011?
Offer a very short reply. 1.1. What is the ratio of the Gross intake ratio(%) in Europe(developing only) in 2009 to that in 2010?
Offer a terse response. 0.96. What is the ratio of the Gross intake ratio(%) in Bhutan in 2009 to that in 2010?
Provide a succinct answer. 1.01. What is the ratio of the Gross intake ratio(%) of Latvia in 2009 to that in 2010?
Keep it short and to the point. 1.02. What is the ratio of the Gross intake ratio(%) in United States in 2009 to that in 2010?
Offer a very short reply. 1.05. What is the ratio of the Gross intake ratio(%) of Europe(developing only) in 2009 to that in 2011?
Make the answer very short. 0.96. What is the ratio of the Gross intake ratio(%) of Bhutan in 2009 to that in 2011?
Provide a short and direct response. 1.1. What is the ratio of the Gross intake ratio(%) of Latvia in 2009 to that in 2011?
Your answer should be compact. 1.1. What is the ratio of the Gross intake ratio(%) of United States in 2009 to that in 2011?
Provide a short and direct response. 1.03. What is the ratio of the Gross intake ratio(%) in Bhutan in 2010 to that in 2011?
Provide a succinct answer. 1.08. What is the ratio of the Gross intake ratio(%) of Latvia in 2010 to that in 2011?
Your answer should be compact. 1.08. What is the ratio of the Gross intake ratio(%) in United States in 2010 to that in 2011?
Provide a succinct answer. 0.98. What is the difference between the highest and the second highest Gross intake ratio(%) of Europe(developing only)?
Ensure brevity in your answer.  0.07. What is the difference between the highest and the second highest Gross intake ratio(%) in Bhutan?
Provide a short and direct response. 1.3. What is the difference between the highest and the second highest Gross intake ratio(%) in Latvia?
Keep it short and to the point. 3.97. What is the difference between the highest and the second highest Gross intake ratio(%) in United States?
Offer a terse response. 1.98. What is the difference between the highest and the lowest Gross intake ratio(%) of Europe(developing only)?
Make the answer very short. 4.46. What is the difference between the highest and the lowest Gross intake ratio(%) of Bhutan?
Provide a short and direct response. 10.48. What is the difference between the highest and the lowest Gross intake ratio(%) in Latvia?
Keep it short and to the point. 16.38. What is the difference between the highest and the lowest Gross intake ratio(%) of United States?
Provide a succinct answer. 12.4. 